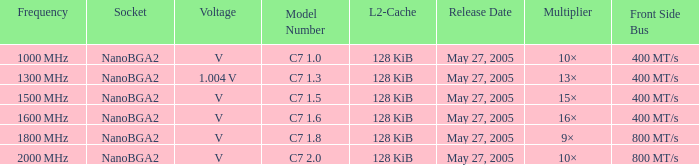What is the frequency of model number c7 1.0? 1000 MHz. I'm looking to parse the entire table for insights. Could you assist me with that? {'header': ['Frequency', 'Socket', 'Voltage', 'Model Number', 'L2-Cache', 'Release Date', 'Multiplier', 'Front Side Bus'], 'rows': [['1000\u2009MHz', 'NanoBGA2', '\u2009V', 'C7 1.0', '128\u2009KiB', 'May 27, 2005', '10×', '400\u2009MT/s'], ['1300\u2009MHz', 'NanoBGA2', '1.004\u2009V', 'C7 1.3', '128\u2009KiB', 'May 27, 2005', '13×', '400\u2009MT/s'], ['1500\u2009MHz', 'NanoBGA2', '\u2009V', 'C7 1.5', '128\u2009KiB', 'May 27, 2005', '15×', '400\u2009MT/s'], ['1600\u2009MHz', 'NanoBGA2', '\u2009V', 'C7 1.6', '128\u2009KiB', 'May 27, 2005', '16×', '400\u2009MT/s'], ['1800\u2009MHz', 'NanoBGA2', '\u2009V', 'C7 1.8', '128\u2009KiB', 'May 27, 2005', '9×', '800\u2009MT/s'], ['2000\u2009MHz', 'NanoBGA2', '\u2009V', 'C7 2.0', '128\u2009KiB', 'May 27, 2005', '10×', '800\u2009MT/s']]} 